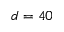Convert formula to latex. <formula><loc_0><loc_0><loc_500><loc_500>d = 4 0</formula> 